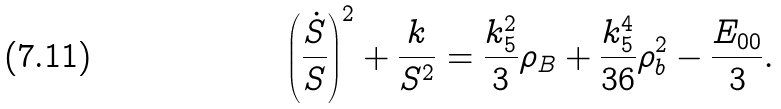<formula> <loc_0><loc_0><loc_500><loc_500>\left ( \frac { \dot { S } } { S } \right ) ^ { 2 } + \frac { k } { S ^ { 2 } } = \frac { k ^ { 2 } _ { 5 } } { 3 } \rho _ { B } + \frac { k ^ { 4 } _ { 5 } } { 3 6 } \rho ^ { 2 } _ { b } - \frac { E _ { 0 0 } } { 3 } .</formula> 